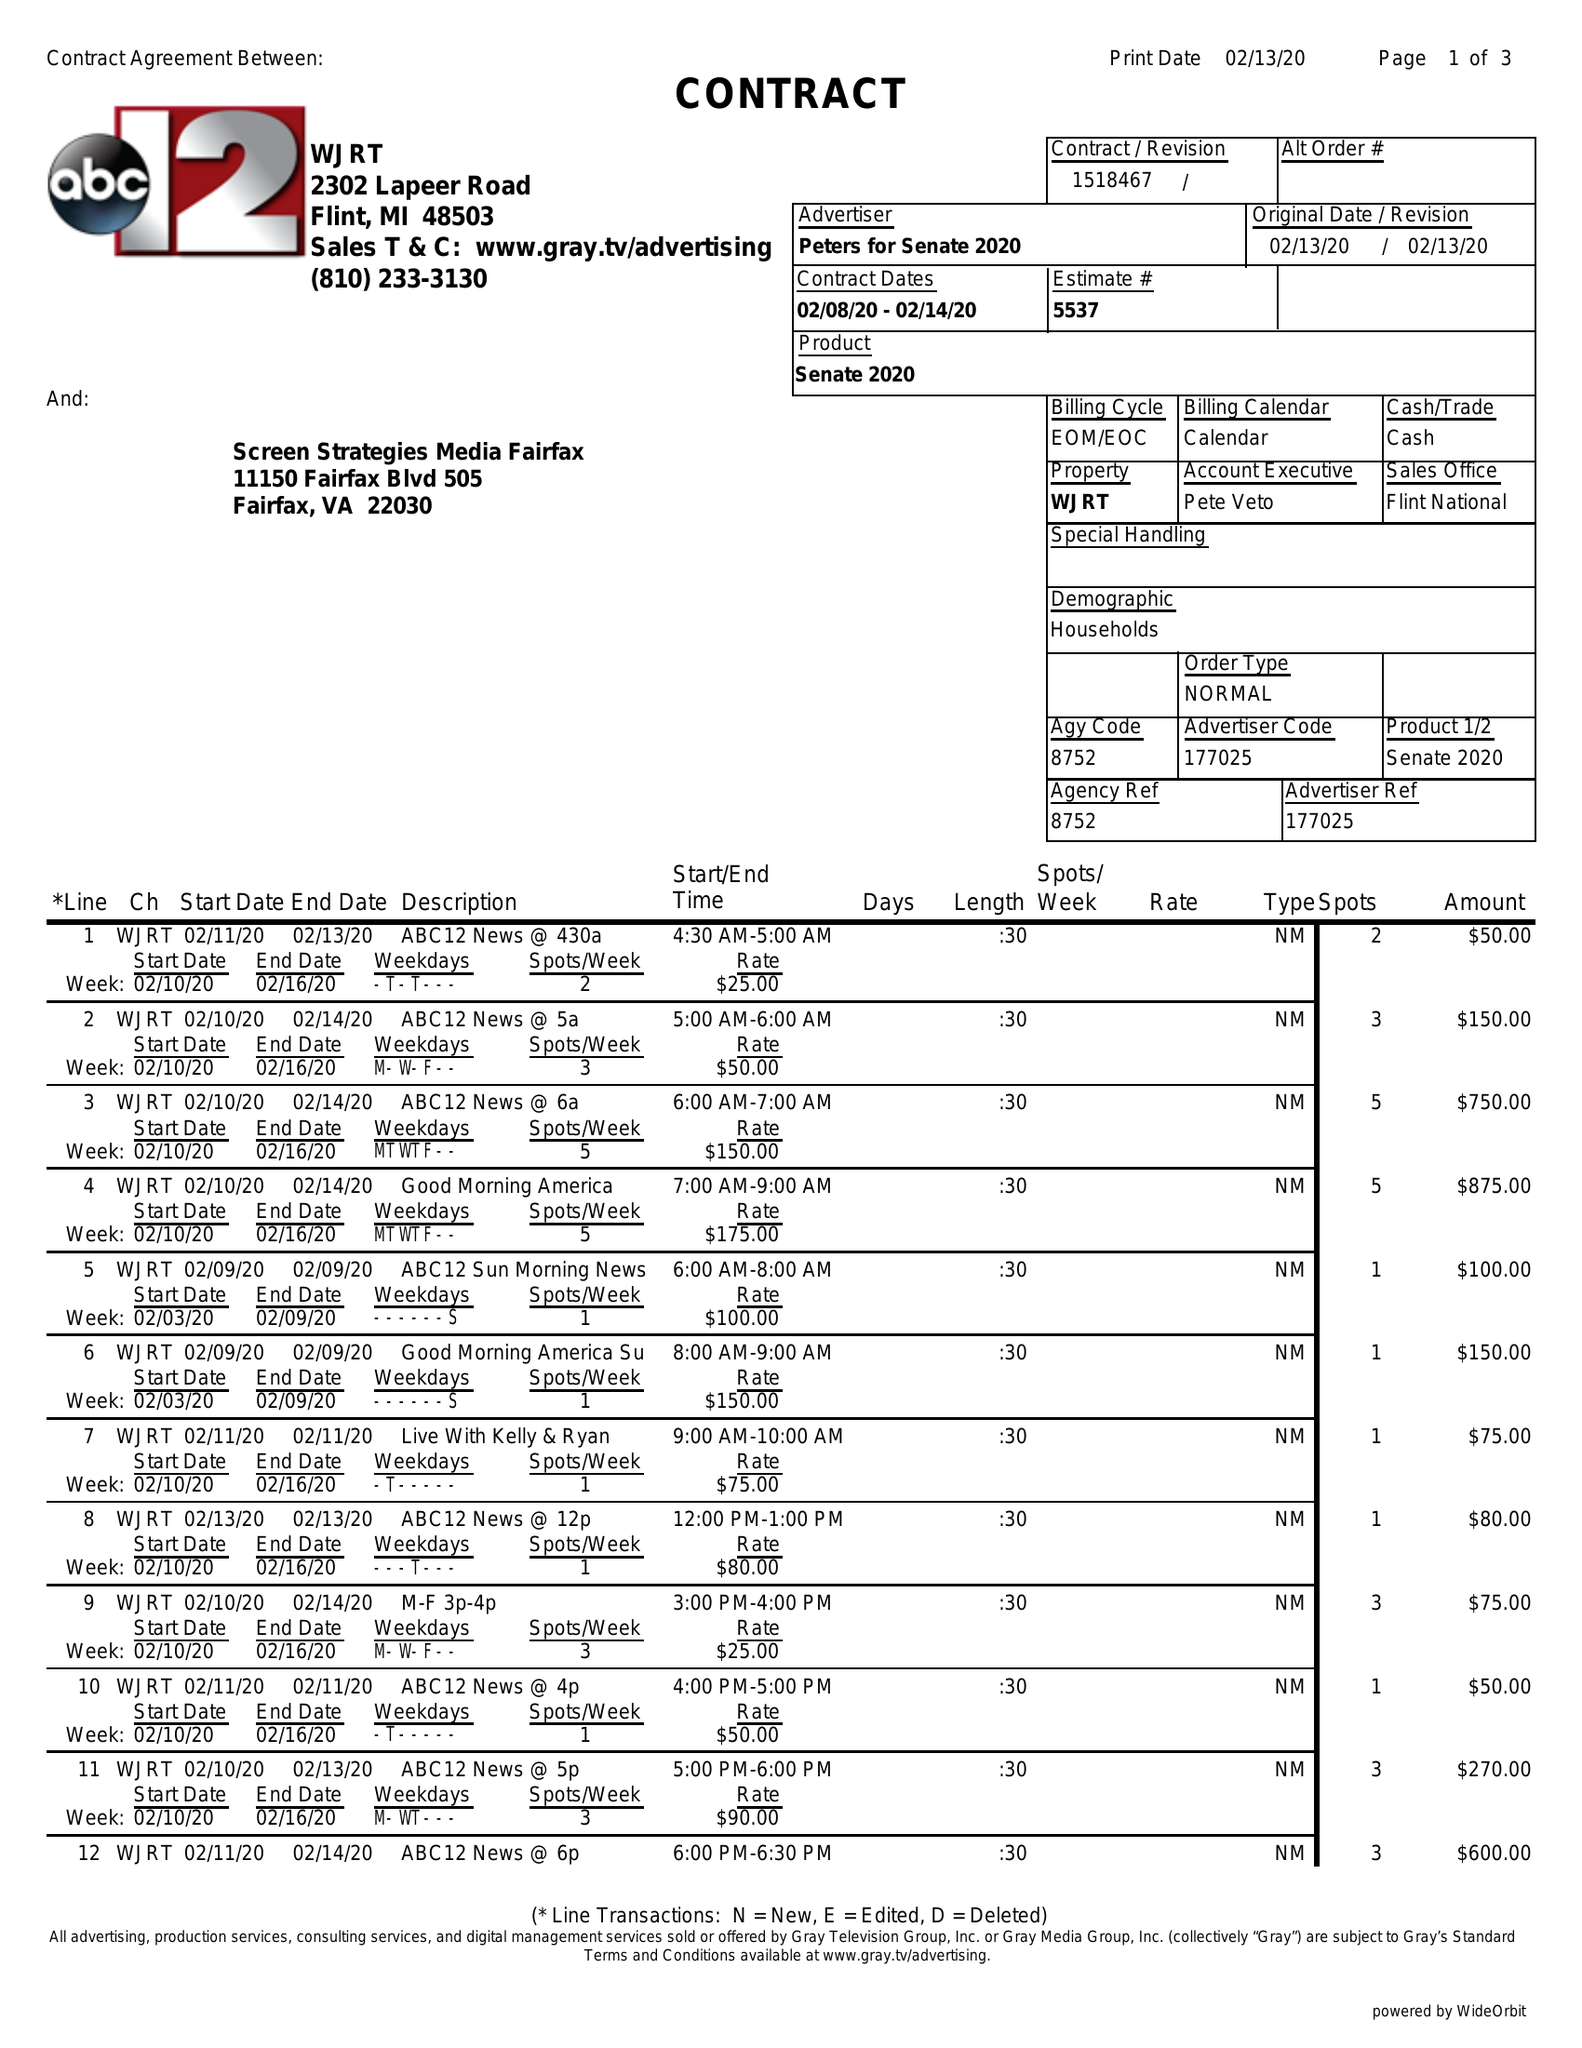What is the value for the advertiser?
Answer the question using a single word or phrase. PETERS FOR SENATE 2020 